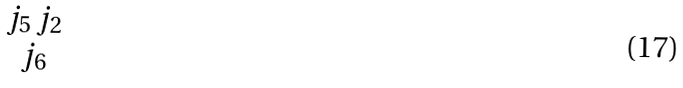<formula> <loc_0><loc_0><loc_500><loc_500>\begin{matrix} j _ { 5 } \, j _ { 2 } \\ j _ { 6 } \end{matrix}</formula> 